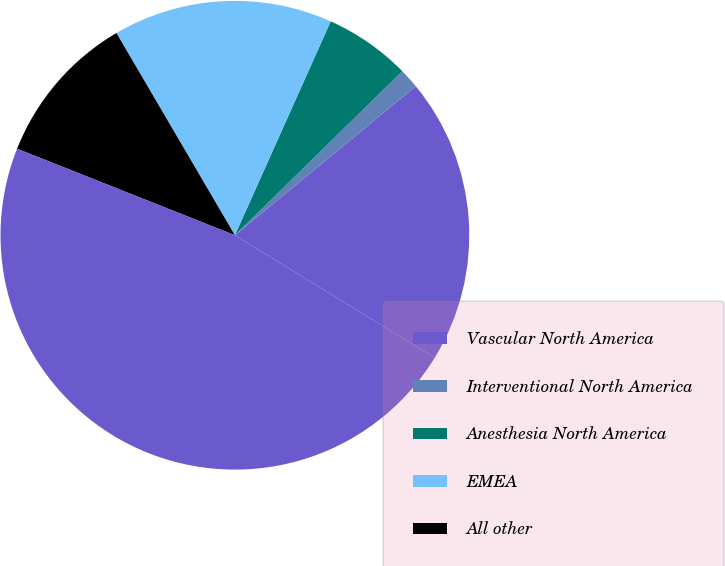Convert chart. <chart><loc_0><loc_0><loc_500><loc_500><pie_chart><fcel>Vascular North America<fcel>Interventional North America<fcel>Anesthesia North America<fcel>EMEA<fcel>All other<fcel>Total restructuring charges<nl><fcel>19.73%<fcel>1.37%<fcel>5.96%<fcel>15.14%<fcel>10.55%<fcel>47.27%<nl></chart> 